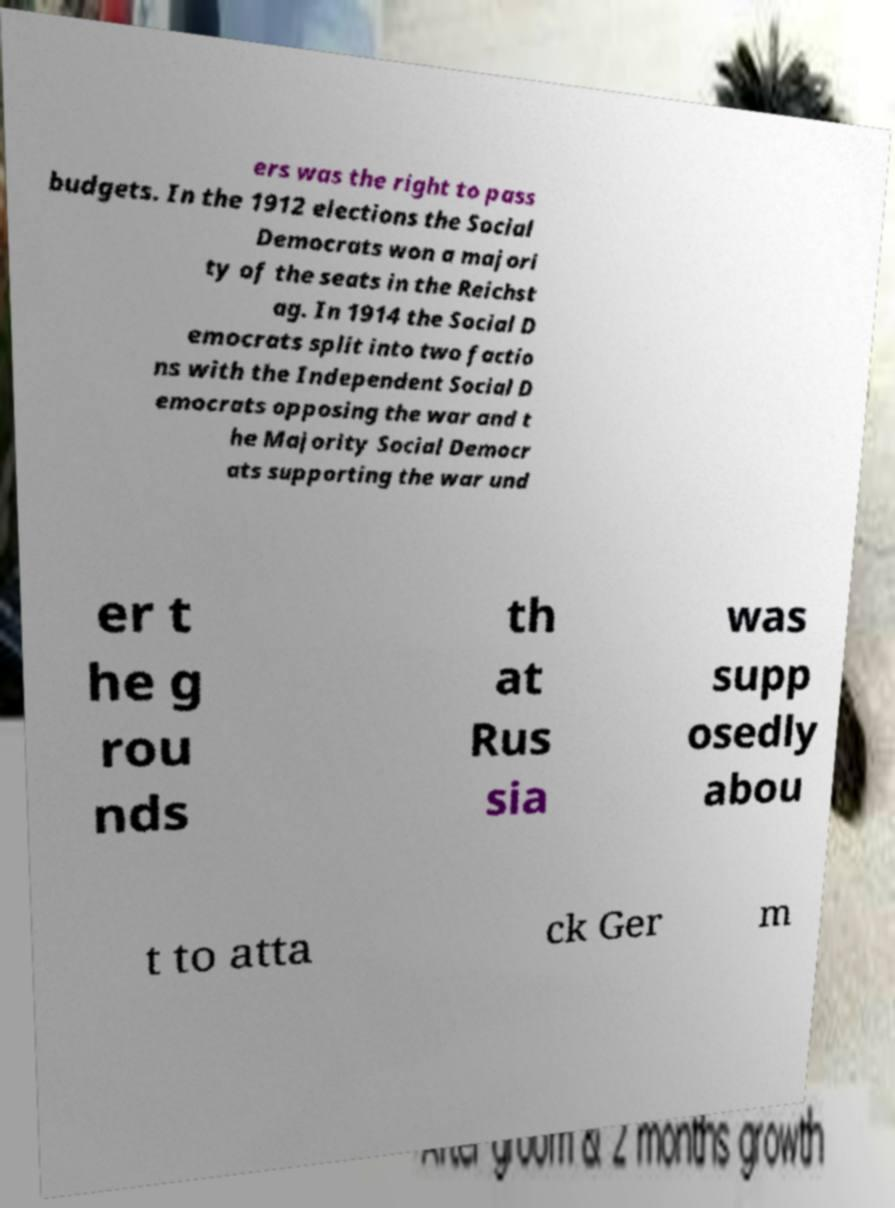Could you extract and type out the text from this image? ers was the right to pass budgets. In the 1912 elections the Social Democrats won a majori ty of the seats in the Reichst ag. In 1914 the Social D emocrats split into two factio ns with the Independent Social D emocrats opposing the war and t he Majority Social Democr ats supporting the war und er t he g rou nds th at Rus sia was supp osedly abou t to atta ck Ger m 